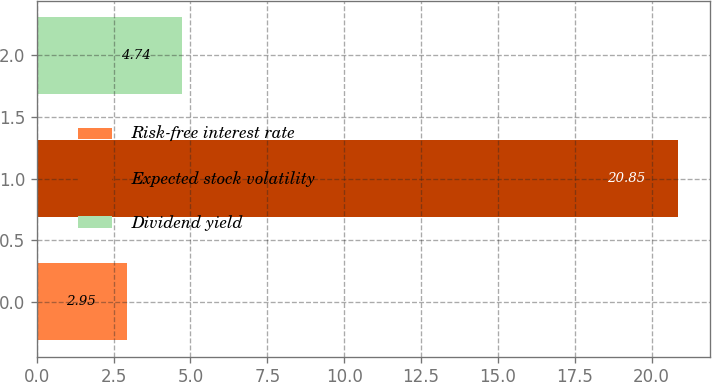<chart> <loc_0><loc_0><loc_500><loc_500><bar_chart><fcel>Risk-free interest rate<fcel>Expected stock volatility<fcel>Dividend yield<nl><fcel>2.95<fcel>20.85<fcel>4.74<nl></chart> 